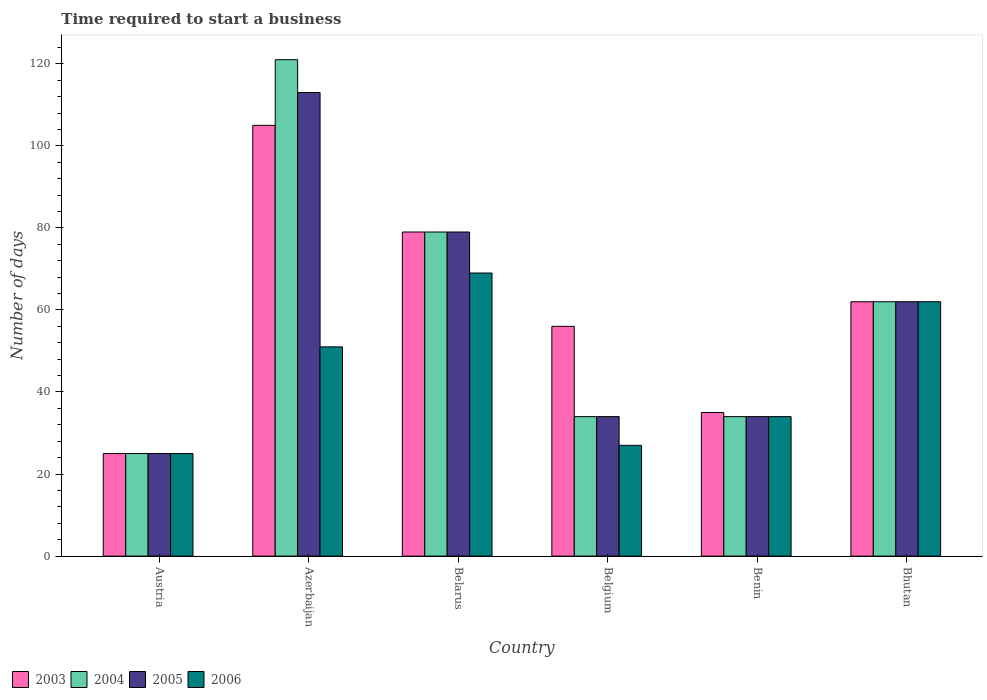Are the number of bars on each tick of the X-axis equal?
Make the answer very short. Yes. What is the label of the 5th group of bars from the left?
Offer a very short reply. Benin. In how many cases, is the number of bars for a given country not equal to the number of legend labels?
Ensure brevity in your answer.  0. What is the number of days required to start a business in 2003 in Azerbaijan?
Give a very brief answer. 105. Across all countries, what is the maximum number of days required to start a business in 2003?
Offer a terse response. 105. Across all countries, what is the minimum number of days required to start a business in 2006?
Your response must be concise. 25. In which country was the number of days required to start a business in 2003 maximum?
Keep it short and to the point. Azerbaijan. In which country was the number of days required to start a business in 2004 minimum?
Offer a terse response. Austria. What is the total number of days required to start a business in 2004 in the graph?
Your answer should be compact. 355. What is the average number of days required to start a business in 2004 per country?
Provide a short and direct response. 59.17. What is the difference between the number of days required to start a business of/in 2006 and number of days required to start a business of/in 2005 in Austria?
Your answer should be compact. 0. What is the ratio of the number of days required to start a business in 2004 in Austria to that in Bhutan?
Keep it short and to the point. 0.4. What is the difference between the highest and the second highest number of days required to start a business in 2006?
Offer a terse response. -18. What is the difference between the highest and the lowest number of days required to start a business in 2005?
Your response must be concise. 88. Is the sum of the number of days required to start a business in 2003 in Belgium and Bhutan greater than the maximum number of days required to start a business in 2004 across all countries?
Your answer should be very brief. No. Is it the case that in every country, the sum of the number of days required to start a business in 2005 and number of days required to start a business in 2006 is greater than the sum of number of days required to start a business in 2004 and number of days required to start a business in 2003?
Keep it short and to the point. No. What does the 3rd bar from the left in Benin represents?
Make the answer very short. 2005. What does the 4th bar from the right in Bhutan represents?
Keep it short and to the point. 2003. Is it the case that in every country, the sum of the number of days required to start a business in 2004 and number of days required to start a business in 2005 is greater than the number of days required to start a business in 2006?
Your answer should be very brief. Yes. How many bars are there?
Provide a short and direct response. 24. What is the difference between two consecutive major ticks on the Y-axis?
Offer a very short reply. 20. Are the values on the major ticks of Y-axis written in scientific E-notation?
Keep it short and to the point. No. Does the graph contain any zero values?
Give a very brief answer. No. Where does the legend appear in the graph?
Your answer should be compact. Bottom left. How are the legend labels stacked?
Your response must be concise. Horizontal. What is the title of the graph?
Offer a very short reply. Time required to start a business. Does "2005" appear as one of the legend labels in the graph?
Give a very brief answer. Yes. What is the label or title of the X-axis?
Keep it short and to the point. Country. What is the label or title of the Y-axis?
Your response must be concise. Number of days. What is the Number of days of 2003 in Austria?
Provide a short and direct response. 25. What is the Number of days in 2004 in Austria?
Offer a terse response. 25. What is the Number of days in 2005 in Austria?
Ensure brevity in your answer.  25. What is the Number of days of 2003 in Azerbaijan?
Ensure brevity in your answer.  105. What is the Number of days of 2004 in Azerbaijan?
Ensure brevity in your answer.  121. What is the Number of days in 2005 in Azerbaijan?
Make the answer very short. 113. What is the Number of days in 2003 in Belarus?
Offer a terse response. 79. What is the Number of days of 2004 in Belarus?
Give a very brief answer. 79. What is the Number of days in 2005 in Belarus?
Your answer should be compact. 79. What is the Number of days of 2003 in Belgium?
Provide a succinct answer. 56. What is the Number of days in 2003 in Benin?
Make the answer very short. 35. What is the Number of days in 2004 in Benin?
Offer a very short reply. 34. What is the Number of days in 2003 in Bhutan?
Keep it short and to the point. 62. What is the Number of days in 2004 in Bhutan?
Provide a succinct answer. 62. Across all countries, what is the maximum Number of days in 2003?
Your response must be concise. 105. Across all countries, what is the maximum Number of days of 2004?
Keep it short and to the point. 121. Across all countries, what is the maximum Number of days in 2005?
Offer a terse response. 113. Across all countries, what is the minimum Number of days in 2003?
Provide a succinct answer. 25. Across all countries, what is the minimum Number of days in 2005?
Offer a terse response. 25. What is the total Number of days of 2003 in the graph?
Provide a short and direct response. 362. What is the total Number of days of 2004 in the graph?
Provide a succinct answer. 355. What is the total Number of days of 2005 in the graph?
Offer a very short reply. 347. What is the total Number of days in 2006 in the graph?
Ensure brevity in your answer.  268. What is the difference between the Number of days of 2003 in Austria and that in Azerbaijan?
Provide a short and direct response. -80. What is the difference between the Number of days of 2004 in Austria and that in Azerbaijan?
Provide a short and direct response. -96. What is the difference between the Number of days of 2005 in Austria and that in Azerbaijan?
Your answer should be compact. -88. What is the difference between the Number of days in 2003 in Austria and that in Belarus?
Ensure brevity in your answer.  -54. What is the difference between the Number of days in 2004 in Austria and that in Belarus?
Offer a terse response. -54. What is the difference between the Number of days in 2005 in Austria and that in Belarus?
Offer a terse response. -54. What is the difference between the Number of days in 2006 in Austria and that in Belarus?
Offer a very short reply. -44. What is the difference between the Number of days in 2003 in Austria and that in Belgium?
Make the answer very short. -31. What is the difference between the Number of days of 2004 in Austria and that in Belgium?
Provide a succinct answer. -9. What is the difference between the Number of days in 2005 in Austria and that in Belgium?
Provide a short and direct response. -9. What is the difference between the Number of days of 2006 in Austria and that in Belgium?
Your response must be concise. -2. What is the difference between the Number of days in 2003 in Austria and that in Benin?
Ensure brevity in your answer.  -10. What is the difference between the Number of days in 2004 in Austria and that in Benin?
Provide a succinct answer. -9. What is the difference between the Number of days of 2006 in Austria and that in Benin?
Your answer should be compact. -9. What is the difference between the Number of days of 2003 in Austria and that in Bhutan?
Keep it short and to the point. -37. What is the difference between the Number of days in 2004 in Austria and that in Bhutan?
Your answer should be very brief. -37. What is the difference between the Number of days of 2005 in Austria and that in Bhutan?
Make the answer very short. -37. What is the difference between the Number of days in 2006 in Austria and that in Bhutan?
Make the answer very short. -37. What is the difference between the Number of days of 2005 in Azerbaijan and that in Belarus?
Give a very brief answer. 34. What is the difference between the Number of days of 2006 in Azerbaijan and that in Belarus?
Your answer should be very brief. -18. What is the difference between the Number of days in 2003 in Azerbaijan and that in Belgium?
Your answer should be very brief. 49. What is the difference between the Number of days in 2004 in Azerbaijan and that in Belgium?
Give a very brief answer. 87. What is the difference between the Number of days of 2005 in Azerbaijan and that in Belgium?
Keep it short and to the point. 79. What is the difference between the Number of days in 2004 in Azerbaijan and that in Benin?
Offer a very short reply. 87. What is the difference between the Number of days in 2005 in Azerbaijan and that in Benin?
Your response must be concise. 79. What is the difference between the Number of days in 2004 in Azerbaijan and that in Bhutan?
Provide a short and direct response. 59. What is the difference between the Number of days in 2006 in Azerbaijan and that in Bhutan?
Offer a very short reply. -11. What is the difference between the Number of days in 2003 in Belarus and that in Belgium?
Your answer should be compact. 23. What is the difference between the Number of days in 2005 in Belarus and that in Benin?
Provide a succinct answer. 45. What is the difference between the Number of days in 2006 in Belarus and that in Benin?
Offer a terse response. 35. What is the difference between the Number of days of 2004 in Belgium and that in Benin?
Provide a short and direct response. 0. What is the difference between the Number of days in 2006 in Belgium and that in Benin?
Offer a very short reply. -7. What is the difference between the Number of days of 2004 in Belgium and that in Bhutan?
Your answer should be compact. -28. What is the difference between the Number of days in 2005 in Belgium and that in Bhutan?
Your answer should be very brief. -28. What is the difference between the Number of days of 2006 in Belgium and that in Bhutan?
Keep it short and to the point. -35. What is the difference between the Number of days of 2003 in Benin and that in Bhutan?
Offer a terse response. -27. What is the difference between the Number of days in 2003 in Austria and the Number of days in 2004 in Azerbaijan?
Offer a very short reply. -96. What is the difference between the Number of days of 2003 in Austria and the Number of days of 2005 in Azerbaijan?
Make the answer very short. -88. What is the difference between the Number of days in 2004 in Austria and the Number of days in 2005 in Azerbaijan?
Your answer should be compact. -88. What is the difference between the Number of days of 2003 in Austria and the Number of days of 2004 in Belarus?
Your answer should be compact. -54. What is the difference between the Number of days of 2003 in Austria and the Number of days of 2005 in Belarus?
Keep it short and to the point. -54. What is the difference between the Number of days of 2003 in Austria and the Number of days of 2006 in Belarus?
Offer a terse response. -44. What is the difference between the Number of days of 2004 in Austria and the Number of days of 2005 in Belarus?
Make the answer very short. -54. What is the difference between the Number of days of 2004 in Austria and the Number of days of 2006 in Belarus?
Your answer should be very brief. -44. What is the difference between the Number of days in 2005 in Austria and the Number of days in 2006 in Belarus?
Give a very brief answer. -44. What is the difference between the Number of days in 2003 in Austria and the Number of days in 2006 in Belgium?
Give a very brief answer. -2. What is the difference between the Number of days of 2004 in Austria and the Number of days of 2006 in Belgium?
Your answer should be compact. -2. What is the difference between the Number of days of 2003 in Austria and the Number of days of 2004 in Benin?
Keep it short and to the point. -9. What is the difference between the Number of days in 2003 in Austria and the Number of days in 2006 in Benin?
Your answer should be compact. -9. What is the difference between the Number of days of 2005 in Austria and the Number of days of 2006 in Benin?
Provide a succinct answer. -9. What is the difference between the Number of days in 2003 in Austria and the Number of days in 2004 in Bhutan?
Ensure brevity in your answer.  -37. What is the difference between the Number of days in 2003 in Austria and the Number of days in 2005 in Bhutan?
Your answer should be very brief. -37. What is the difference between the Number of days in 2003 in Austria and the Number of days in 2006 in Bhutan?
Offer a terse response. -37. What is the difference between the Number of days in 2004 in Austria and the Number of days in 2005 in Bhutan?
Offer a very short reply. -37. What is the difference between the Number of days of 2004 in Austria and the Number of days of 2006 in Bhutan?
Provide a short and direct response. -37. What is the difference between the Number of days of 2005 in Austria and the Number of days of 2006 in Bhutan?
Your response must be concise. -37. What is the difference between the Number of days in 2003 in Azerbaijan and the Number of days in 2006 in Belarus?
Your answer should be very brief. 36. What is the difference between the Number of days in 2004 in Azerbaijan and the Number of days in 2005 in Belarus?
Offer a very short reply. 42. What is the difference between the Number of days in 2004 in Azerbaijan and the Number of days in 2006 in Belarus?
Offer a very short reply. 52. What is the difference between the Number of days of 2005 in Azerbaijan and the Number of days of 2006 in Belarus?
Offer a very short reply. 44. What is the difference between the Number of days of 2004 in Azerbaijan and the Number of days of 2006 in Belgium?
Keep it short and to the point. 94. What is the difference between the Number of days in 2005 in Azerbaijan and the Number of days in 2006 in Belgium?
Offer a very short reply. 86. What is the difference between the Number of days in 2004 in Azerbaijan and the Number of days in 2005 in Benin?
Provide a short and direct response. 87. What is the difference between the Number of days in 2004 in Azerbaijan and the Number of days in 2006 in Benin?
Ensure brevity in your answer.  87. What is the difference between the Number of days of 2005 in Azerbaijan and the Number of days of 2006 in Benin?
Make the answer very short. 79. What is the difference between the Number of days of 2003 in Azerbaijan and the Number of days of 2004 in Bhutan?
Ensure brevity in your answer.  43. What is the difference between the Number of days in 2003 in Azerbaijan and the Number of days in 2006 in Bhutan?
Keep it short and to the point. 43. What is the difference between the Number of days in 2004 in Azerbaijan and the Number of days in 2006 in Bhutan?
Give a very brief answer. 59. What is the difference between the Number of days of 2005 in Azerbaijan and the Number of days of 2006 in Bhutan?
Offer a very short reply. 51. What is the difference between the Number of days in 2003 in Belarus and the Number of days in 2004 in Belgium?
Keep it short and to the point. 45. What is the difference between the Number of days in 2003 in Belarus and the Number of days in 2005 in Belgium?
Your answer should be very brief. 45. What is the difference between the Number of days of 2004 in Belarus and the Number of days of 2005 in Belgium?
Offer a terse response. 45. What is the difference between the Number of days of 2004 in Belarus and the Number of days of 2006 in Belgium?
Make the answer very short. 52. What is the difference between the Number of days in 2003 in Belarus and the Number of days in 2005 in Benin?
Give a very brief answer. 45. What is the difference between the Number of days in 2003 in Belarus and the Number of days in 2006 in Benin?
Keep it short and to the point. 45. What is the difference between the Number of days in 2004 in Belarus and the Number of days in 2005 in Benin?
Your answer should be very brief. 45. What is the difference between the Number of days in 2004 in Belarus and the Number of days in 2006 in Benin?
Make the answer very short. 45. What is the difference between the Number of days in 2003 in Belarus and the Number of days in 2005 in Bhutan?
Offer a very short reply. 17. What is the difference between the Number of days of 2004 in Belarus and the Number of days of 2006 in Bhutan?
Give a very brief answer. 17. What is the difference between the Number of days in 2005 in Belarus and the Number of days in 2006 in Bhutan?
Make the answer very short. 17. What is the difference between the Number of days in 2004 in Belgium and the Number of days in 2006 in Benin?
Give a very brief answer. 0. What is the difference between the Number of days of 2004 in Belgium and the Number of days of 2005 in Bhutan?
Offer a terse response. -28. What is the difference between the Number of days of 2004 in Belgium and the Number of days of 2006 in Bhutan?
Offer a terse response. -28. What is the difference between the Number of days of 2005 in Belgium and the Number of days of 2006 in Bhutan?
Provide a succinct answer. -28. What is the difference between the Number of days of 2003 in Benin and the Number of days of 2004 in Bhutan?
Ensure brevity in your answer.  -27. What is the difference between the Number of days of 2004 in Benin and the Number of days of 2005 in Bhutan?
Keep it short and to the point. -28. What is the average Number of days in 2003 per country?
Offer a terse response. 60.33. What is the average Number of days in 2004 per country?
Keep it short and to the point. 59.17. What is the average Number of days in 2005 per country?
Your answer should be compact. 57.83. What is the average Number of days of 2006 per country?
Provide a short and direct response. 44.67. What is the difference between the Number of days in 2003 and Number of days in 2005 in Austria?
Ensure brevity in your answer.  0. What is the difference between the Number of days of 2003 and Number of days of 2006 in Austria?
Your answer should be very brief. 0. What is the difference between the Number of days in 2004 and Number of days in 2005 in Austria?
Your answer should be very brief. 0. What is the difference between the Number of days in 2005 and Number of days in 2006 in Austria?
Keep it short and to the point. 0. What is the difference between the Number of days in 2003 and Number of days in 2004 in Azerbaijan?
Ensure brevity in your answer.  -16. What is the difference between the Number of days in 2003 and Number of days in 2006 in Azerbaijan?
Provide a short and direct response. 54. What is the difference between the Number of days in 2004 and Number of days in 2005 in Azerbaijan?
Keep it short and to the point. 8. What is the difference between the Number of days in 2004 and Number of days in 2006 in Azerbaijan?
Offer a very short reply. 70. What is the difference between the Number of days in 2003 and Number of days in 2006 in Belarus?
Provide a short and direct response. 10. What is the difference between the Number of days in 2003 and Number of days in 2005 in Belgium?
Offer a very short reply. 22. What is the difference between the Number of days in 2003 and Number of days in 2006 in Belgium?
Make the answer very short. 29. What is the difference between the Number of days in 2004 and Number of days in 2005 in Belgium?
Provide a short and direct response. 0. What is the difference between the Number of days of 2005 and Number of days of 2006 in Belgium?
Make the answer very short. 7. What is the difference between the Number of days of 2003 and Number of days of 2004 in Benin?
Your response must be concise. 1. What is the difference between the Number of days of 2003 and Number of days of 2005 in Benin?
Your answer should be compact. 1. What is the difference between the Number of days in 2004 and Number of days in 2005 in Benin?
Keep it short and to the point. 0. What is the difference between the Number of days in 2004 and Number of days in 2006 in Benin?
Offer a very short reply. 0. What is the difference between the Number of days of 2005 and Number of days of 2006 in Benin?
Offer a very short reply. 0. What is the difference between the Number of days of 2003 and Number of days of 2004 in Bhutan?
Ensure brevity in your answer.  0. What is the difference between the Number of days of 2003 and Number of days of 2006 in Bhutan?
Provide a succinct answer. 0. What is the difference between the Number of days in 2004 and Number of days in 2006 in Bhutan?
Offer a terse response. 0. What is the difference between the Number of days of 2005 and Number of days of 2006 in Bhutan?
Give a very brief answer. 0. What is the ratio of the Number of days in 2003 in Austria to that in Azerbaijan?
Give a very brief answer. 0.24. What is the ratio of the Number of days of 2004 in Austria to that in Azerbaijan?
Give a very brief answer. 0.21. What is the ratio of the Number of days of 2005 in Austria to that in Azerbaijan?
Ensure brevity in your answer.  0.22. What is the ratio of the Number of days in 2006 in Austria to that in Azerbaijan?
Offer a very short reply. 0.49. What is the ratio of the Number of days of 2003 in Austria to that in Belarus?
Offer a terse response. 0.32. What is the ratio of the Number of days of 2004 in Austria to that in Belarus?
Provide a short and direct response. 0.32. What is the ratio of the Number of days of 2005 in Austria to that in Belarus?
Provide a succinct answer. 0.32. What is the ratio of the Number of days in 2006 in Austria to that in Belarus?
Provide a succinct answer. 0.36. What is the ratio of the Number of days of 2003 in Austria to that in Belgium?
Your response must be concise. 0.45. What is the ratio of the Number of days in 2004 in Austria to that in Belgium?
Your response must be concise. 0.74. What is the ratio of the Number of days in 2005 in Austria to that in Belgium?
Offer a terse response. 0.74. What is the ratio of the Number of days of 2006 in Austria to that in Belgium?
Your answer should be compact. 0.93. What is the ratio of the Number of days in 2003 in Austria to that in Benin?
Make the answer very short. 0.71. What is the ratio of the Number of days of 2004 in Austria to that in Benin?
Ensure brevity in your answer.  0.74. What is the ratio of the Number of days of 2005 in Austria to that in Benin?
Your answer should be compact. 0.74. What is the ratio of the Number of days of 2006 in Austria to that in Benin?
Provide a succinct answer. 0.74. What is the ratio of the Number of days in 2003 in Austria to that in Bhutan?
Make the answer very short. 0.4. What is the ratio of the Number of days of 2004 in Austria to that in Bhutan?
Ensure brevity in your answer.  0.4. What is the ratio of the Number of days in 2005 in Austria to that in Bhutan?
Keep it short and to the point. 0.4. What is the ratio of the Number of days of 2006 in Austria to that in Bhutan?
Provide a short and direct response. 0.4. What is the ratio of the Number of days in 2003 in Azerbaijan to that in Belarus?
Provide a short and direct response. 1.33. What is the ratio of the Number of days in 2004 in Azerbaijan to that in Belarus?
Provide a short and direct response. 1.53. What is the ratio of the Number of days in 2005 in Azerbaijan to that in Belarus?
Keep it short and to the point. 1.43. What is the ratio of the Number of days in 2006 in Azerbaijan to that in Belarus?
Offer a very short reply. 0.74. What is the ratio of the Number of days in 2003 in Azerbaijan to that in Belgium?
Your response must be concise. 1.88. What is the ratio of the Number of days in 2004 in Azerbaijan to that in Belgium?
Offer a very short reply. 3.56. What is the ratio of the Number of days in 2005 in Azerbaijan to that in Belgium?
Keep it short and to the point. 3.32. What is the ratio of the Number of days in 2006 in Azerbaijan to that in Belgium?
Your answer should be very brief. 1.89. What is the ratio of the Number of days in 2004 in Azerbaijan to that in Benin?
Give a very brief answer. 3.56. What is the ratio of the Number of days of 2005 in Azerbaijan to that in Benin?
Offer a terse response. 3.32. What is the ratio of the Number of days of 2003 in Azerbaijan to that in Bhutan?
Your answer should be very brief. 1.69. What is the ratio of the Number of days in 2004 in Azerbaijan to that in Bhutan?
Your answer should be very brief. 1.95. What is the ratio of the Number of days of 2005 in Azerbaijan to that in Bhutan?
Ensure brevity in your answer.  1.82. What is the ratio of the Number of days in 2006 in Azerbaijan to that in Bhutan?
Offer a very short reply. 0.82. What is the ratio of the Number of days in 2003 in Belarus to that in Belgium?
Your answer should be very brief. 1.41. What is the ratio of the Number of days in 2004 in Belarus to that in Belgium?
Give a very brief answer. 2.32. What is the ratio of the Number of days in 2005 in Belarus to that in Belgium?
Ensure brevity in your answer.  2.32. What is the ratio of the Number of days in 2006 in Belarus to that in Belgium?
Your answer should be compact. 2.56. What is the ratio of the Number of days in 2003 in Belarus to that in Benin?
Offer a terse response. 2.26. What is the ratio of the Number of days of 2004 in Belarus to that in Benin?
Offer a very short reply. 2.32. What is the ratio of the Number of days in 2005 in Belarus to that in Benin?
Make the answer very short. 2.32. What is the ratio of the Number of days of 2006 in Belarus to that in Benin?
Keep it short and to the point. 2.03. What is the ratio of the Number of days in 2003 in Belarus to that in Bhutan?
Provide a succinct answer. 1.27. What is the ratio of the Number of days of 2004 in Belarus to that in Bhutan?
Your answer should be very brief. 1.27. What is the ratio of the Number of days in 2005 in Belarus to that in Bhutan?
Provide a short and direct response. 1.27. What is the ratio of the Number of days in 2006 in Belarus to that in Bhutan?
Give a very brief answer. 1.11. What is the ratio of the Number of days of 2003 in Belgium to that in Benin?
Give a very brief answer. 1.6. What is the ratio of the Number of days in 2005 in Belgium to that in Benin?
Provide a succinct answer. 1. What is the ratio of the Number of days in 2006 in Belgium to that in Benin?
Your answer should be compact. 0.79. What is the ratio of the Number of days in 2003 in Belgium to that in Bhutan?
Provide a succinct answer. 0.9. What is the ratio of the Number of days of 2004 in Belgium to that in Bhutan?
Make the answer very short. 0.55. What is the ratio of the Number of days in 2005 in Belgium to that in Bhutan?
Offer a very short reply. 0.55. What is the ratio of the Number of days of 2006 in Belgium to that in Bhutan?
Make the answer very short. 0.44. What is the ratio of the Number of days in 2003 in Benin to that in Bhutan?
Offer a very short reply. 0.56. What is the ratio of the Number of days of 2004 in Benin to that in Bhutan?
Keep it short and to the point. 0.55. What is the ratio of the Number of days of 2005 in Benin to that in Bhutan?
Give a very brief answer. 0.55. What is the ratio of the Number of days in 2006 in Benin to that in Bhutan?
Make the answer very short. 0.55. What is the difference between the highest and the second highest Number of days in 2003?
Your answer should be very brief. 26. What is the difference between the highest and the second highest Number of days of 2004?
Your response must be concise. 42. What is the difference between the highest and the second highest Number of days in 2005?
Ensure brevity in your answer.  34. What is the difference between the highest and the second highest Number of days of 2006?
Provide a short and direct response. 7. What is the difference between the highest and the lowest Number of days of 2004?
Keep it short and to the point. 96. What is the difference between the highest and the lowest Number of days in 2005?
Provide a short and direct response. 88. 